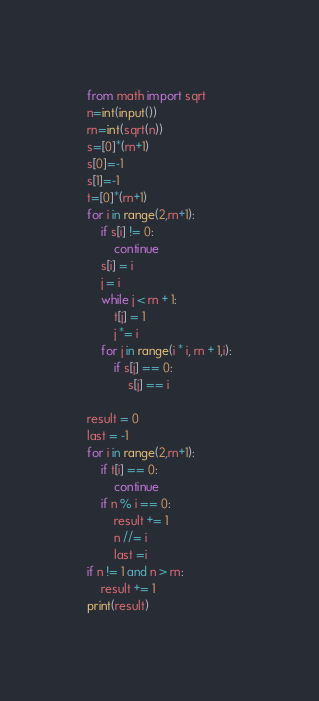<code> <loc_0><loc_0><loc_500><loc_500><_Python_>from math import sqrt
n=int(input())
rn=int(sqrt(n))
s=[0]*(rn+1)
s[0]=-1
s[1]=-1
t=[0]*(rn+1)
for i in range(2,rn+1):
    if s[i] != 0:
        continue
    s[i] = i
    j = i
    while j < rn + 1:
        t[j] = 1
        j *= i
    for j in range(i * i, rn + 1,i):
        if s[j] == 0:
            s[j] == i

result = 0
last = -1
for i in range(2,rn+1):
    if t[i] == 0:
        continue
    if n % i == 0:
        result += 1
        n //= i
        last =i
if n != 1 and n > rn:
    result += 1
print(result)</code> 